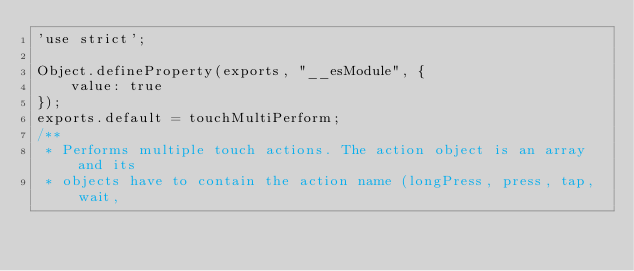Convert code to text. <code><loc_0><loc_0><loc_500><loc_500><_JavaScript_>'use strict';

Object.defineProperty(exports, "__esModule", {
    value: true
});
exports.default = touchMultiPerform;
/**
 * Performs multiple touch actions. The action object is an array and its
 * objects have to contain the action name (longPress, press, tap, wait,</code> 